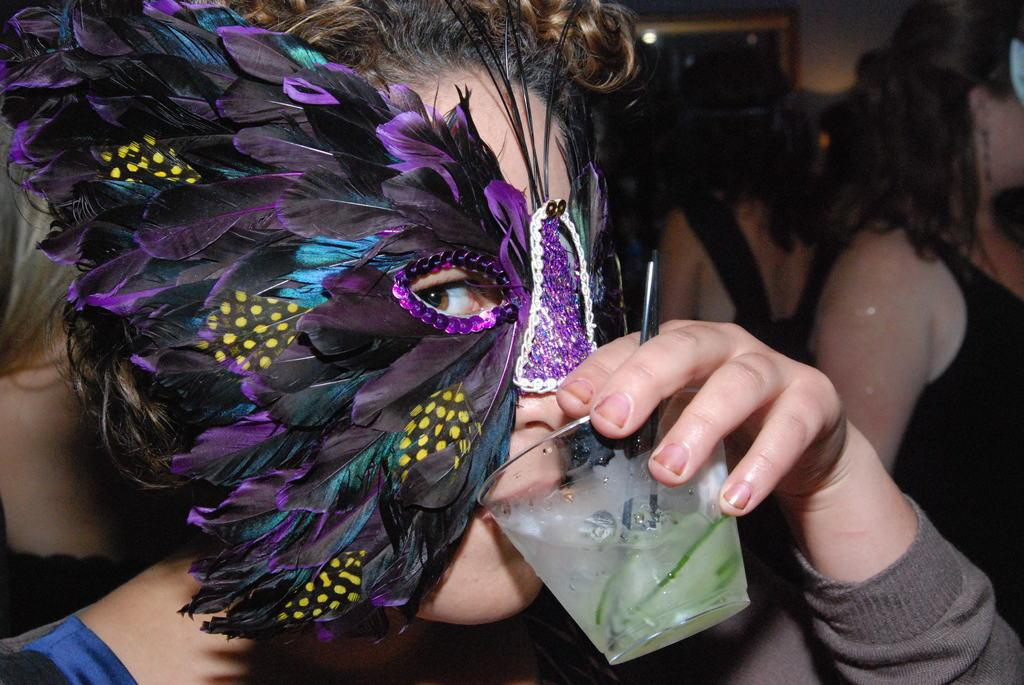How many people are in the image? There are a few people in the image. What is one person holding in the image? One person is holding a glass. What can be seen in the background of the image? There is a window and a light visible in the background. What type of robin can be seen sitting on the scissors in the image? There is no robin or scissors present in the image. 